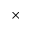Convert formula to latex. <formula><loc_0><loc_0><loc_500><loc_500>\times</formula> 